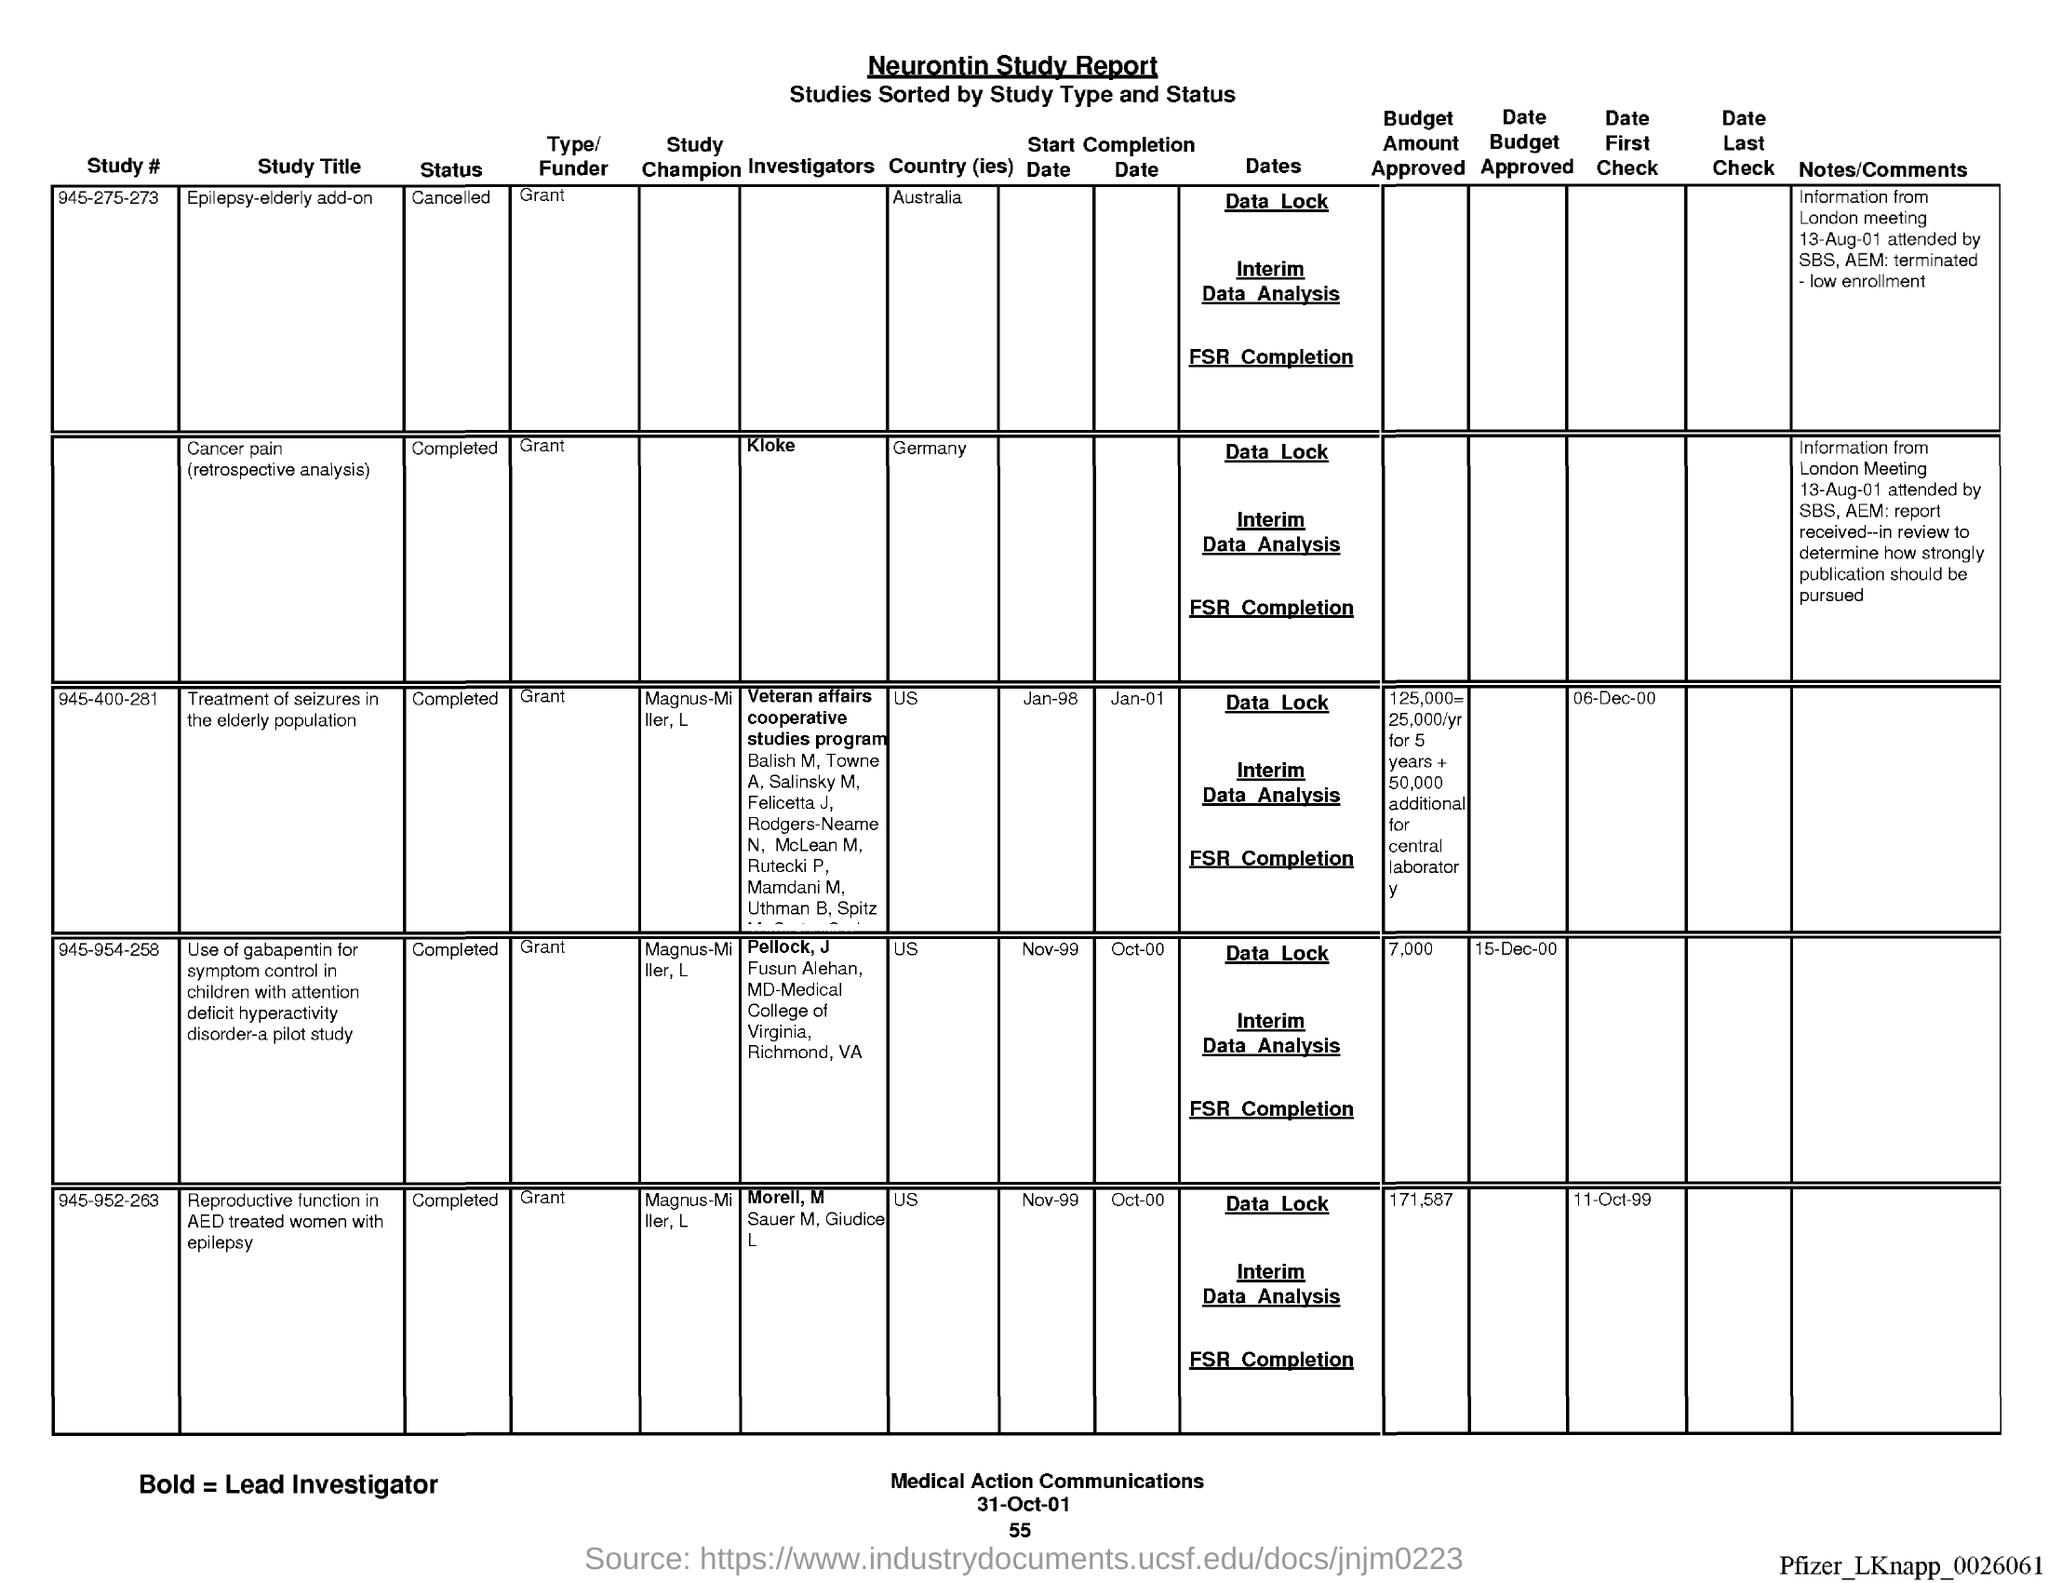What is the name of the report ?
Ensure brevity in your answer.  Neurontin Study report. What is the date at bottom of the page?
Your answer should be compact. 31-oct-01. What is the page number below date?
Your response must be concise. 55. 